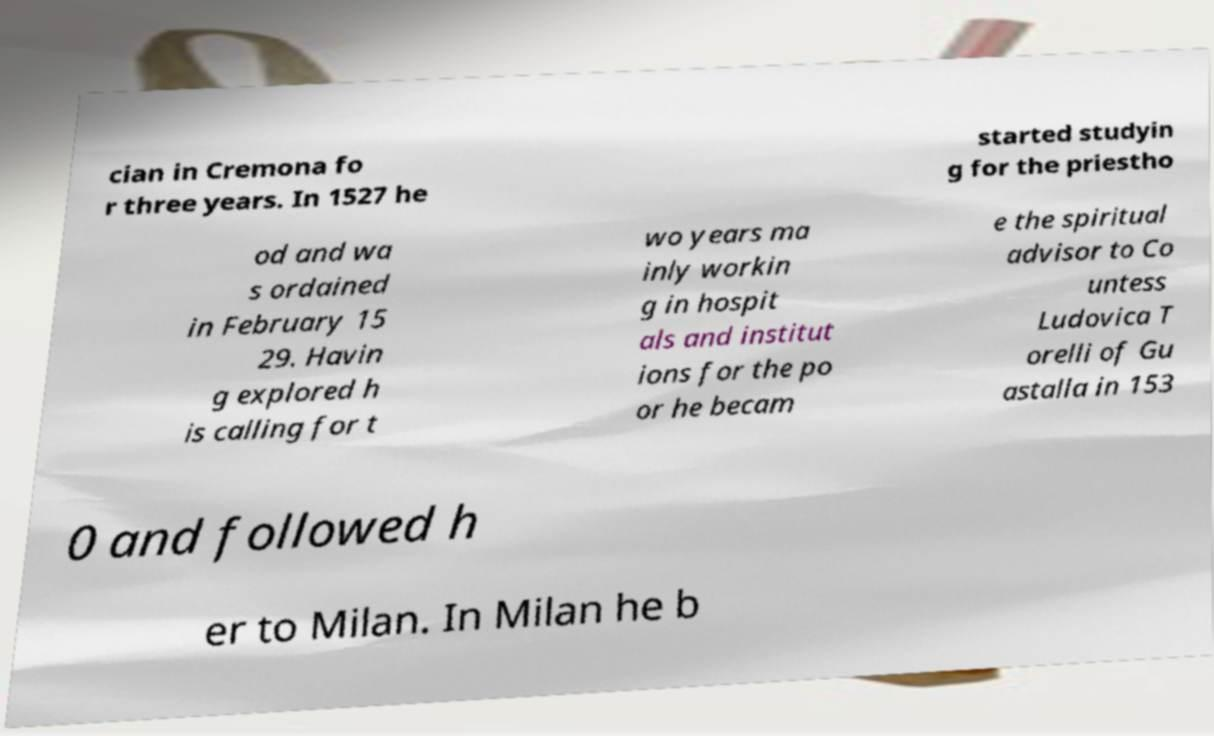Could you extract and type out the text from this image? cian in Cremona fo r three years. In 1527 he started studyin g for the priestho od and wa s ordained in February 15 29. Havin g explored h is calling for t wo years ma inly workin g in hospit als and institut ions for the po or he becam e the spiritual advisor to Co untess Ludovica T orelli of Gu astalla in 153 0 and followed h er to Milan. In Milan he b 